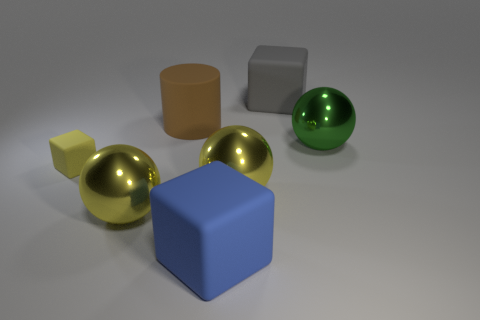Add 2 green spheres. How many objects exist? 9 Subtract all cubes. How many objects are left? 4 Add 2 small yellow cubes. How many small yellow cubes are left? 3 Add 7 gray objects. How many gray objects exist? 8 Subtract 0 purple balls. How many objects are left? 7 Subtract all small yellow blocks. Subtract all yellow matte cubes. How many objects are left? 5 